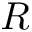Convert formula to latex. <formula><loc_0><loc_0><loc_500><loc_500>R</formula> 